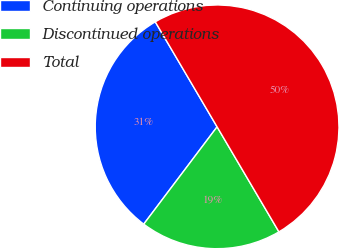Convert chart. <chart><loc_0><loc_0><loc_500><loc_500><pie_chart><fcel>Continuing operations<fcel>Discontinued operations<fcel>Total<nl><fcel>31.25%<fcel>18.75%<fcel>50.0%<nl></chart> 